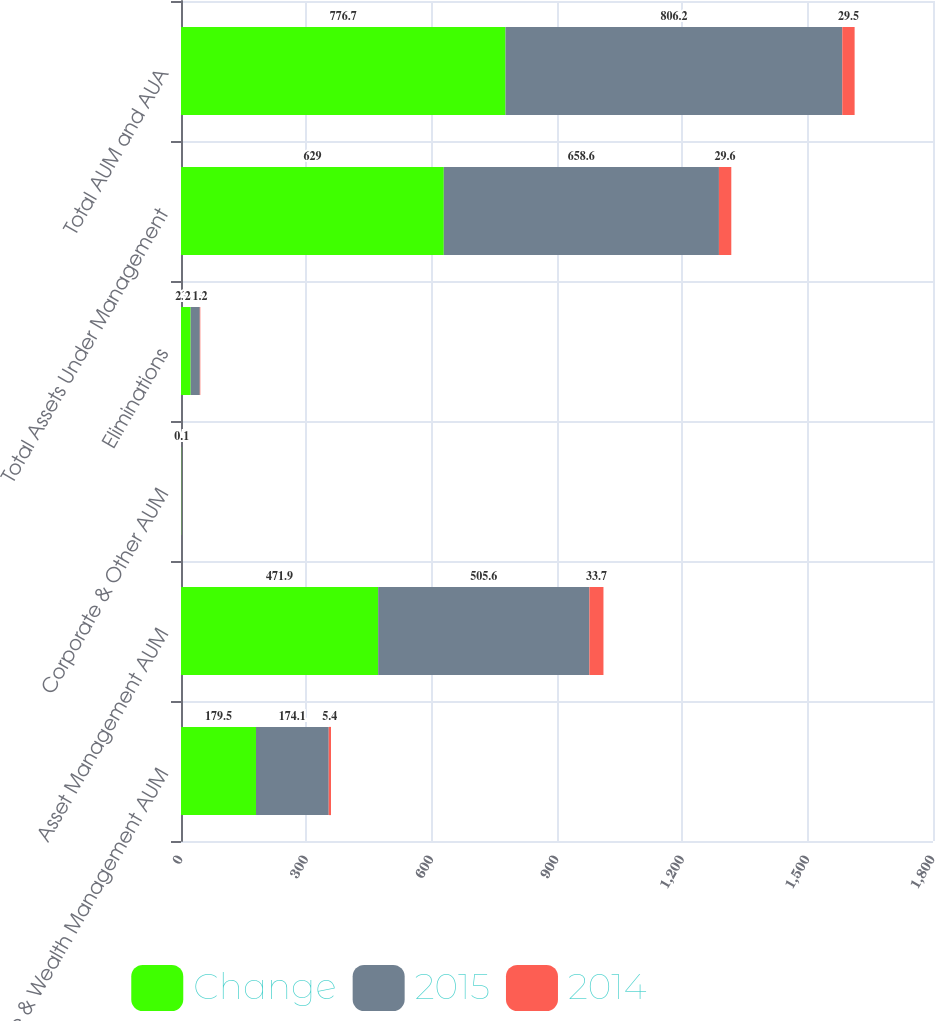<chart> <loc_0><loc_0><loc_500><loc_500><stacked_bar_chart><ecel><fcel>Advice & Wealth Management AUM<fcel>Asset Management AUM<fcel>Corporate & Other AUM<fcel>Eliminations<fcel>Total Assets Under Management<fcel>Total AUM and AUA<nl><fcel>Change<fcel>179.5<fcel>471.9<fcel>0.7<fcel>23.1<fcel>629<fcel>776.7<nl><fcel>2015<fcel>174.1<fcel>505.6<fcel>0.8<fcel>21.9<fcel>658.6<fcel>806.2<nl><fcel>2014<fcel>5.4<fcel>33.7<fcel>0.1<fcel>1.2<fcel>29.6<fcel>29.5<nl></chart> 